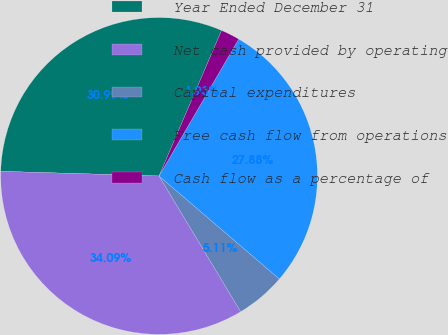Convert chart to OTSL. <chart><loc_0><loc_0><loc_500><loc_500><pie_chart><fcel>Year Ended December 31<fcel>Net cash provided by operating<fcel>Capital expenditures<fcel>Free cash flow from operations<fcel>Cash flow as a percentage of<nl><fcel>30.99%<fcel>34.09%<fcel>5.11%<fcel>27.88%<fcel>1.93%<nl></chart> 